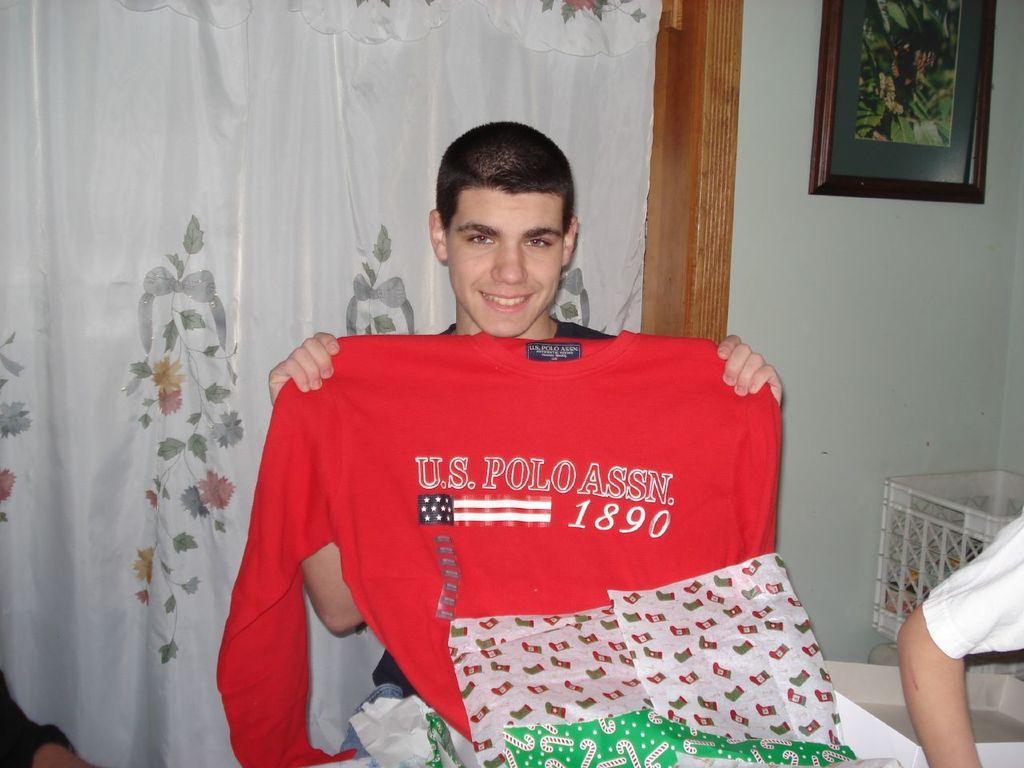Please provide a concise description of this image. The picture is taken in a room. In the center of the picture there is a man holding a t-shirt. On the right there is a person's hand and a basket. At the top to the right there is a frame on the wall. Behind the man there is a curtain. 